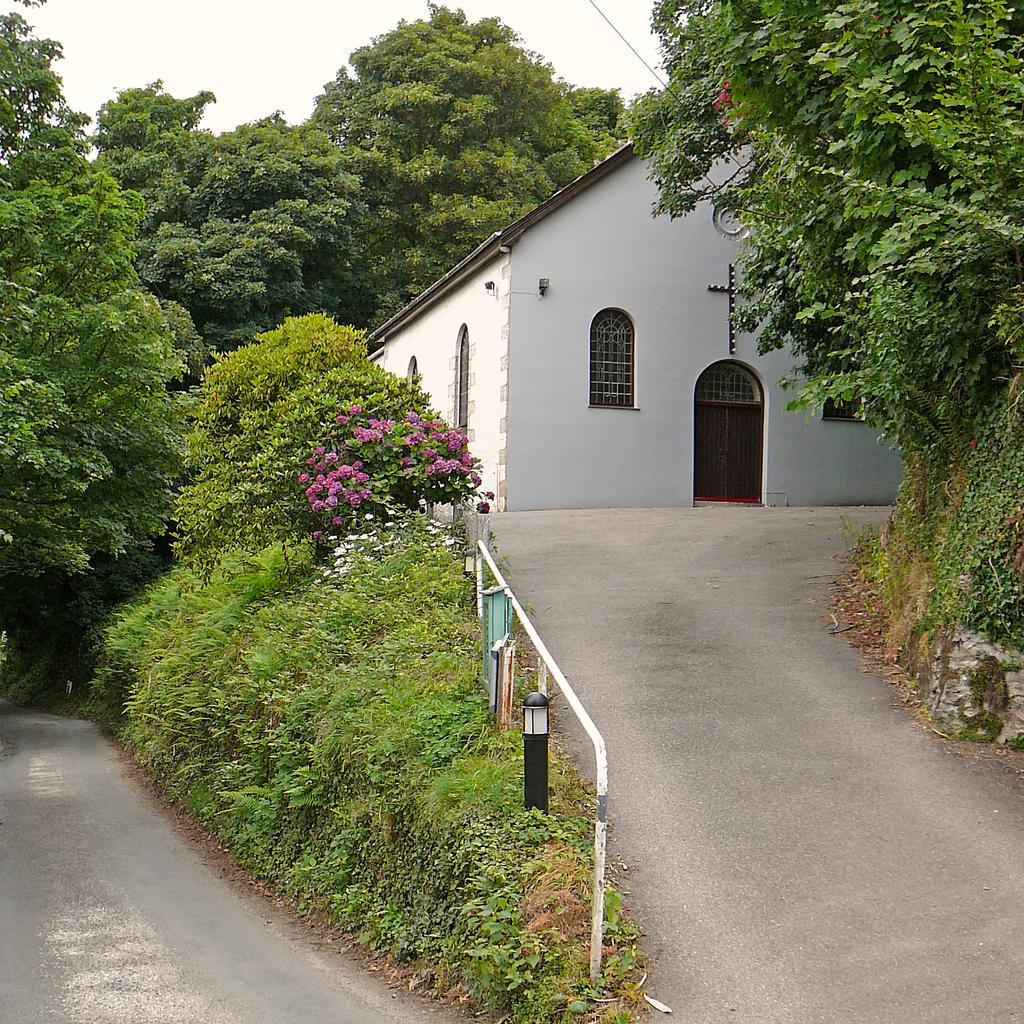How would you summarize this image in a sentence or two? In the foreground of this image, there is a road curve, few plants, railing and the trees. In the background, there is a shelter, trees and the sky. 